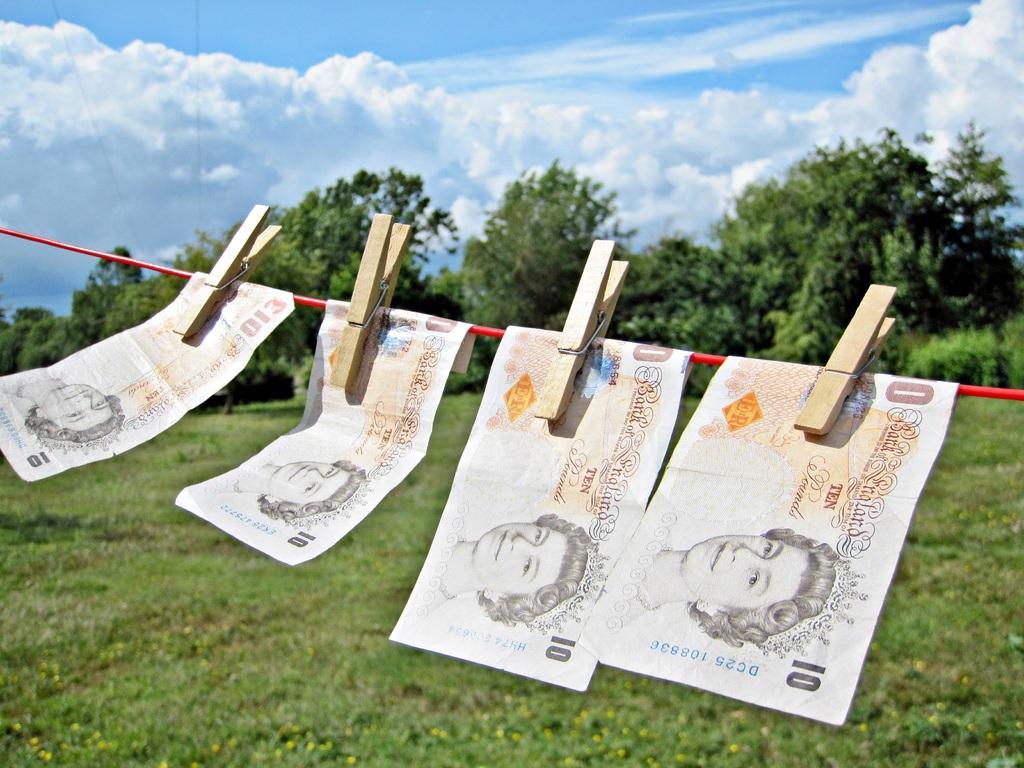What is the denomination of these bills?
Ensure brevity in your answer.  10. How much money are these worth?
Your answer should be compact. 10. 